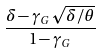Convert formula to latex. <formula><loc_0><loc_0><loc_500><loc_500>\frac { \delta - \gamma _ { G } \sqrt { \delta / \theta } } { 1 - \gamma _ { G } }</formula> 